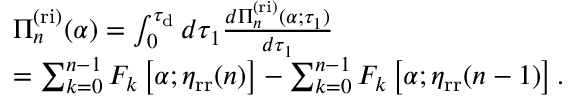Convert formula to latex. <formula><loc_0><loc_0><loc_500><loc_500>\begin{array} { r l } & { \Pi _ { n } ^ { ( r i ) } ( \alpha ) = \int _ { 0 } ^ { \tau _ { d } } d \tau _ { 1 } \frac { d \Pi _ { n } ^ { ( r i ) } ( \alpha ; \tau _ { 1 } ) } { d \tau _ { 1 } } } \\ & { = \sum _ { k = 0 } ^ { n - 1 } F _ { k } \left [ \alpha ; \eta _ { r r } ( n ) \right ] - \sum _ { k = 0 } ^ { n - 1 } F _ { k } \left [ \alpha ; \eta _ { r r } ( n - 1 ) \right ] . } \end{array}</formula> 